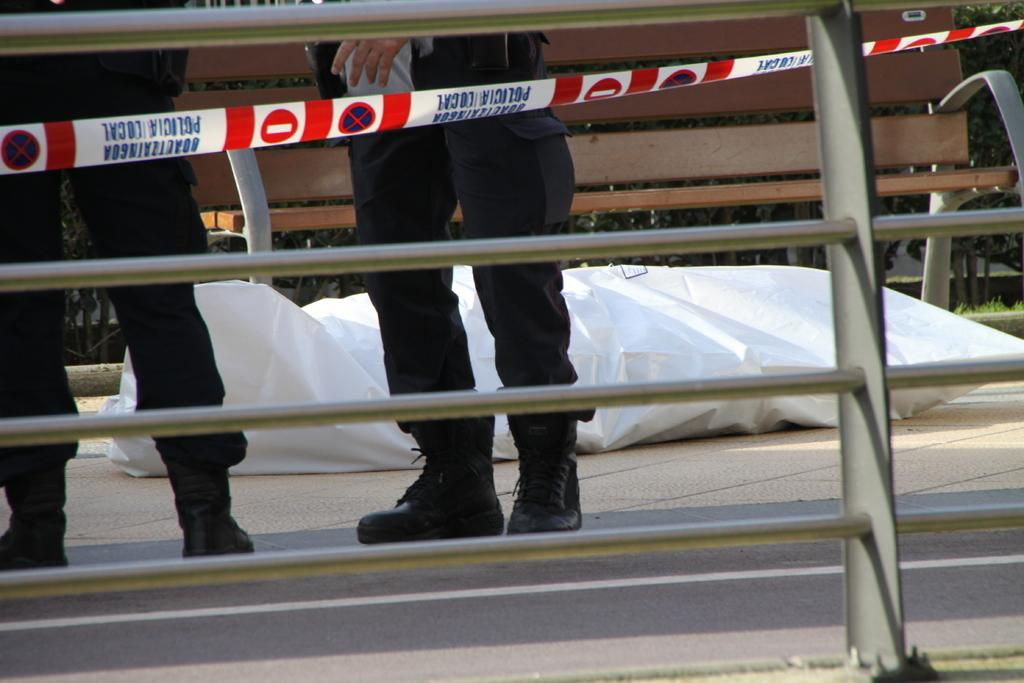What can be seen in the foreground of the image? There is a railing in the picture. What is happening in the background of the image? There are two people standing in the background. Can you describe any objects visible in the background? There are some objects visible in the background, but their specific nature is not mentioned in the provided facts. What color is the feather that one of the people is holding in the image? There is no mention of a feather or any object being held by the people in the image. 